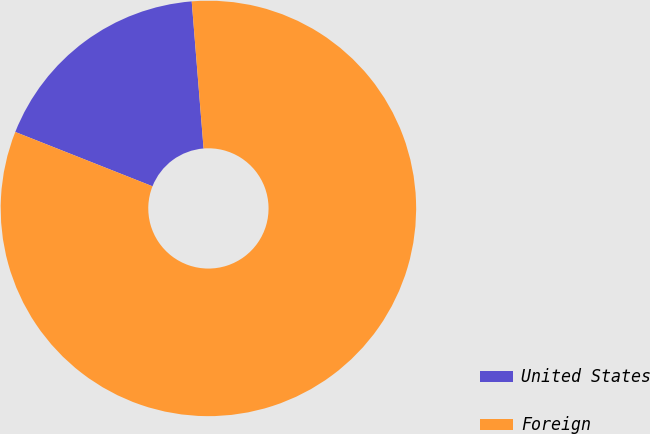Convert chart. <chart><loc_0><loc_0><loc_500><loc_500><pie_chart><fcel>United States<fcel>Foreign<nl><fcel>17.72%<fcel>82.28%<nl></chart> 